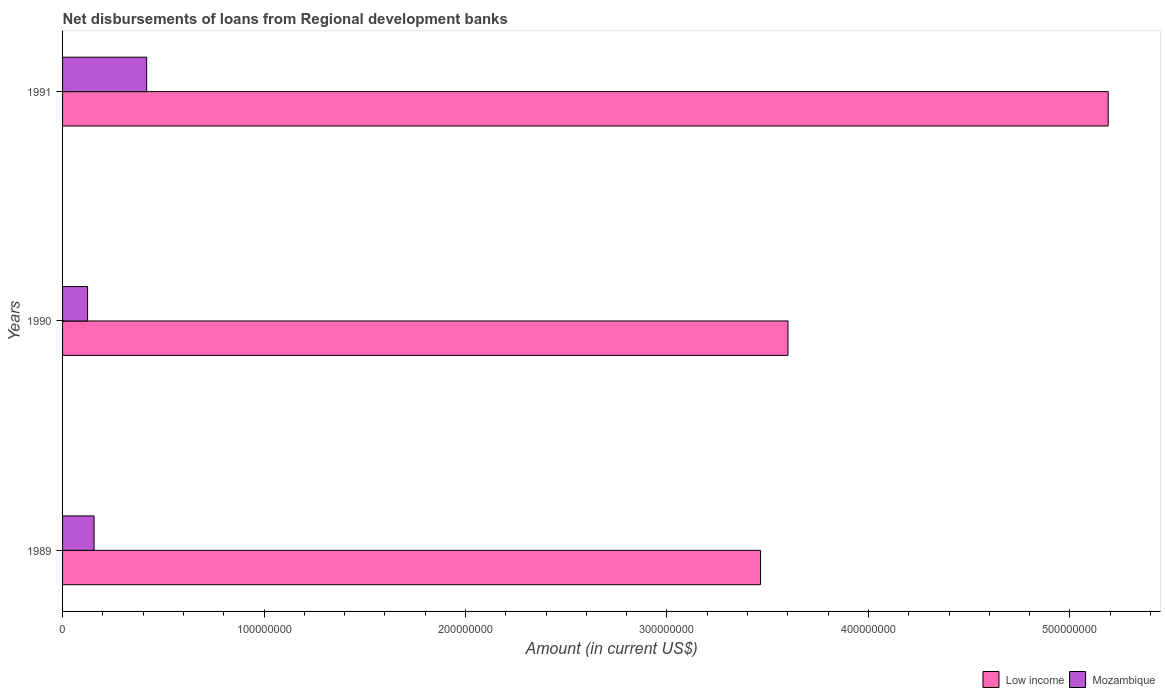How many groups of bars are there?
Provide a succinct answer. 3. Are the number of bars per tick equal to the number of legend labels?
Offer a very short reply. Yes. How many bars are there on the 1st tick from the bottom?
Make the answer very short. 2. What is the label of the 1st group of bars from the top?
Your answer should be compact. 1991. What is the amount of disbursements of loans from regional development banks in Mozambique in 1991?
Offer a very short reply. 4.17e+07. Across all years, what is the maximum amount of disbursements of loans from regional development banks in Mozambique?
Give a very brief answer. 4.17e+07. Across all years, what is the minimum amount of disbursements of loans from regional development banks in Low income?
Offer a very short reply. 3.46e+08. In which year was the amount of disbursements of loans from regional development banks in Mozambique maximum?
Your answer should be very brief. 1991. What is the total amount of disbursements of loans from regional development banks in Mozambique in the graph?
Your answer should be compact. 6.98e+07. What is the difference between the amount of disbursements of loans from regional development banks in Mozambique in 1989 and that in 1990?
Provide a succinct answer. 3.22e+06. What is the difference between the amount of disbursements of loans from regional development banks in Mozambique in 1990 and the amount of disbursements of loans from regional development banks in Low income in 1989?
Offer a very short reply. -3.34e+08. What is the average amount of disbursements of loans from regional development banks in Low income per year?
Your response must be concise. 4.09e+08. In the year 1990, what is the difference between the amount of disbursements of loans from regional development banks in Low income and amount of disbursements of loans from regional development banks in Mozambique?
Give a very brief answer. 3.48e+08. In how many years, is the amount of disbursements of loans from regional development banks in Low income greater than 300000000 US$?
Your answer should be compact. 3. What is the ratio of the amount of disbursements of loans from regional development banks in Low income in 1989 to that in 1991?
Offer a very short reply. 0.67. Is the amount of disbursements of loans from regional development banks in Low income in 1989 less than that in 1990?
Offer a very short reply. Yes. What is the difference between the highest and the second highest amount of disbursements of loans from regional development banks in Mozambique?
Offer a terse response. 2.61e+07. What is the difference between the highest and the lowest amount of disbursements of loans from regional development banks in Low income?
Ensure brevity in your answer.  1.73e+08. In how many years, is the amount of disbursements of loans from regional development banks in Mozambique greater than the average amount of disbursements of loans from regional development banks in Mozambique taken over all years?
Keep it short and to the point. 1. Is the sum of the amount of disbursements of loans from regional development banks in Mozambique in 1989 and 1991 greater than the maximum amount of disbursements of loans from regional development banks in Low income across all years?
Your answer should be compact. No. What does the 1st bar from the top in 1991 represents?
Provide a short and direct response. Mozambique. What does the 2nd bar from the bottom in 1989 represents?
Give a very brief answer. Mozambique. How many bars are there?
Provide a short and direct response. 6. How many years are there in the graph?
Your answer should be compact. 3. Where does the legend appear in the graph?
Your answer should be compact. Bottom right. How are the legend labels stacked?
Offer a very short reply. Horizontal. What is the title of the graph?
Ensure brevity in your answer.  Net disbursements of loans from Regional development banks. Does "Timor-Leste" appear as one of the legend labels in the graph?
Give a very brief answer. No. What is the label or title of the X-axis?
Provide a succinct answer. Amount (in current US$). What is the label or title of the Y-axis?
Your answer should be compact. Years. What is the Amount (in current US$) of Low income in 1989?
Offer a very short reply. 3.46e+08. What is the Amount (in current US$) in Mozambique in 1989?
Your answer should be very brief. 1.56e+07. What is the Amount (in current US$) in Low income in 1990?
Make the answer very short. 3.60e+08. What is the Amount (in current US$) of Mozambique in 1990?
Make the answer very short. 1.24e+07. What is the Amount (in current US$) of Low income in 1991?
Provide a short and direct response. 5.19e+08. What is the Amount (in current US$) in Mozambique in 1991?
Keep it short and to the point. 4.17e+07. Across all years, what is the maximum Amount (in current US$) in Low income?
Your answer should be compact. 5.19e+08. Across all years, what is the maximum Amount (in current US$) of Mozambique?
Make the answer very short. 4.17e+07. Across all years, what is the minimum Amount (in current US$) of Low income?
Offer a terse response. 3.46e+08. Across all years, what is the minimum Amount (in current US$) in Mozambique?
Make the answer very short. 1.24e+07. What is the total Amount (in current US$) of Low income in the graph?
Your answer should be compact. 1.23e+09. What is the total Amount (in current US$) in Mozambique in the graph?
Offer a very short reply. 6.98e+07. What is the difference between the Amount (in current US$) of Low income in 1989 and that in 1990?
Your response must be concise. -1.36e+07. What is the difference between the Amount (in current US$) of Mozambique in 1989 and that in 1990?
Your response must be concise. 3.22e+06. What is the difference between the Amount (in current US$) of Low income in 1989 and that in 1991?
Give a very brief answer. -1.73e+08. What is the difference between the Amount (in current US$) in Mozambique in 1989 and that in 1991?
Keep it short and to the point. -2.61e+07. What is the difference between the Amount (in current US$) of Low income in 1990 and that in 1991?
Ensure brevity in your answer.  -1.59e+08. What is the difference between the Amount (in current US$) of Mozambique in 1990 and that in 1991?
Offer a terse response. -2.93e+07. What is the difference between the Amount (in current US$) of Low income in 1989 and the Amount (in current US$) of Mozambique in 1990?
Offer a terse response. 3.34e+08. What is the difference between the Amount (in current US$) of Low income in 1989 and the Amount (in current US$) of Mozambique in 1991?
Ensure brevity in your answer.  3.05e+08. What is the difference between the Amount (in current US$) of Low income in 1990 and the Amount (in current US$) of Mozambique in 1991?
Ensure brevity in your answer.  3.18e+08. What is the average Amount (in current US$) of Low income per year?
Offer a terse response. 4.09e+08. What is the average Amount (in current US$) in Mozambique per year?
Provide a short and direct response. 2.33e+07. In the year 1989, what is the difference between the Amount (in current US$) of Low income and Amount (in current US$) of Mozambique?
Give a very brief answer. 3.31e+08. In the year 1990, what is the difference between the Amount (in current US$) in Low income and Amount (in current US$) in Mozambique?
Provide a succinct answer. 3.48e+08. In the year 1991, what is the difference between the Amount (in current US$) of Low income and Amount (in current US$) of Mozambique?
Offer a very short reply. 4.77e+08. What is the ratio of the Amount (in current US$) of Low income in 1989 to that in 1990?
Offer a terse response. 0.96. What is the ratio of the Amount (in current US$) of Mozambique in 1989 to that in 1990?
Provide a succinct answer. 1.26. What is the ratio of the Amount (in current US$) of Low income in 1989 to that in 1991?
Make the answer very short. 0.67. What is the ratio of the Amount (in current US$) of Mozambique in 1989 to that in 1991?
Provide a short and direct response. 0.37. What is the ratio of the Amount (in current US$) of Low income in 1990 to that in 1991?
Offer a very short reply. 0.69. What is the ratio of the Amount (in current US$) in Mozambique in 1990 to that in 1991?
Provide a succinct answer. 0.3. What is the difference between the highest and the second highest Amount (in current US$) in Low income?
Make the answer very short. 1.59e+08. What is the difference between the highest and the second highest Amount (in current US$) of Mozambique?
Make the answer very short. 2.61e+07. What is the difference between the highest and the lowest Amount (in current US$) in Low income?
Make the answer very short. 1.73e+08. What is the difference between the highest and the lowest Amount (in current US$) in Mozambique?
Offer a very short reply. 2.93e+07. 